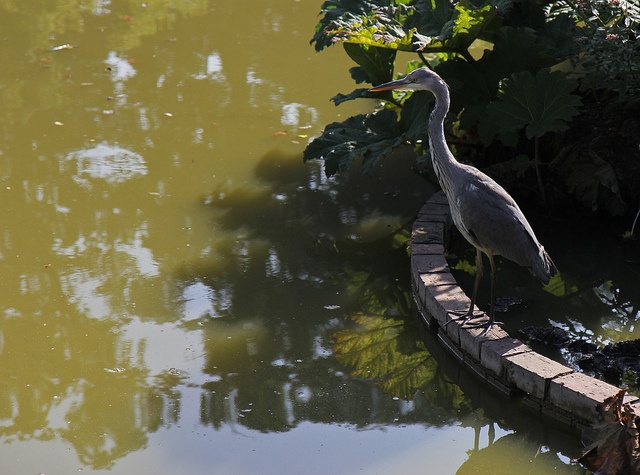Describe the objects in this image and their specific colors. I can see a bird in olive, black, gray, and darkgray tones in this image. 